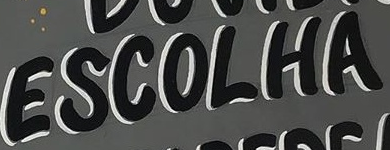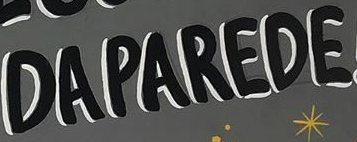What words are shown in these images in order, separated by a semicolon? ESCOLHA; DAPAREDE 